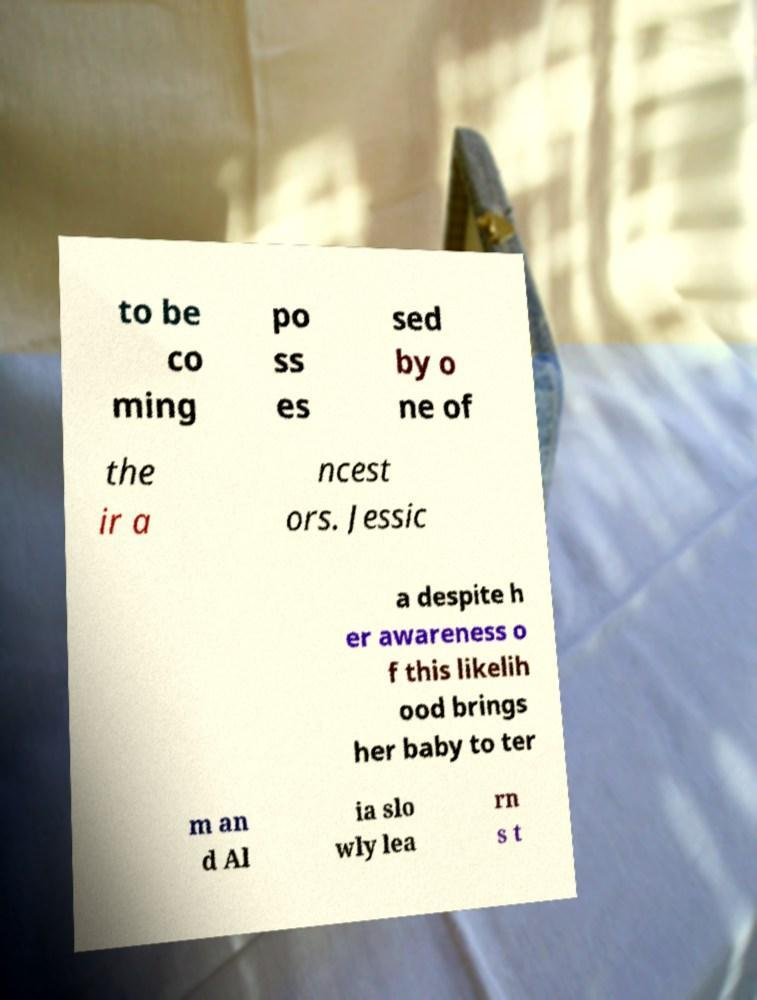Could you assist in decoding the text presented in this image and type it out clearly? to be co ming po ss es sed by o ne of the ir a ncest ors. Jessic a despite h er awareness o f this likelih ood brings her baby to ter m an d Al ia slo wly lea rn s t 